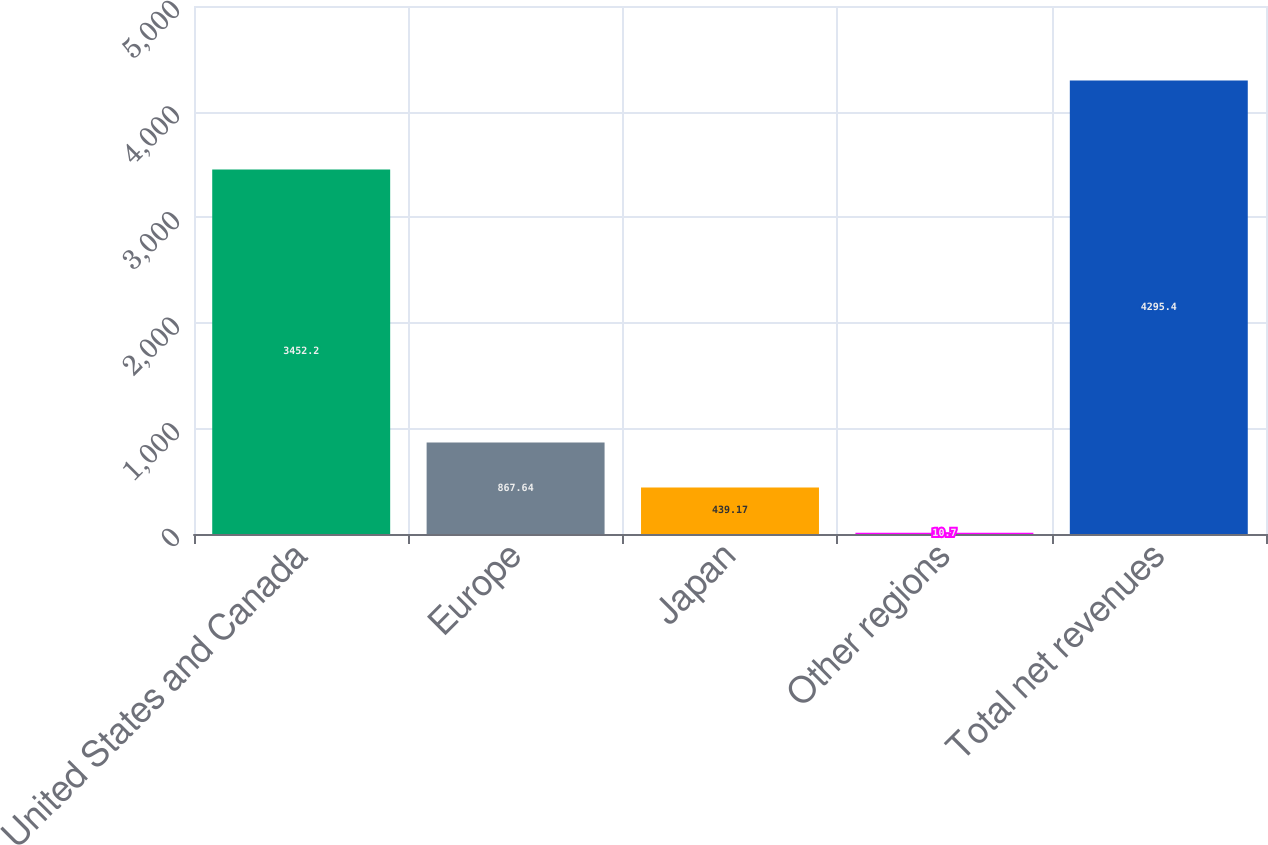Convert chart to OTSL. <chart><loc_0><loc_0><loc_500><loc_500><bar_chart><fcel>United States and Canada<fcel>Europe<fcel>Japan<fcel>Other regions<fcel>Total net revenues<nl><fcel>3452.2<fcel>867.64<fcel>439.17<fcel>10.7<fcel>4295.4<nl></chart> 